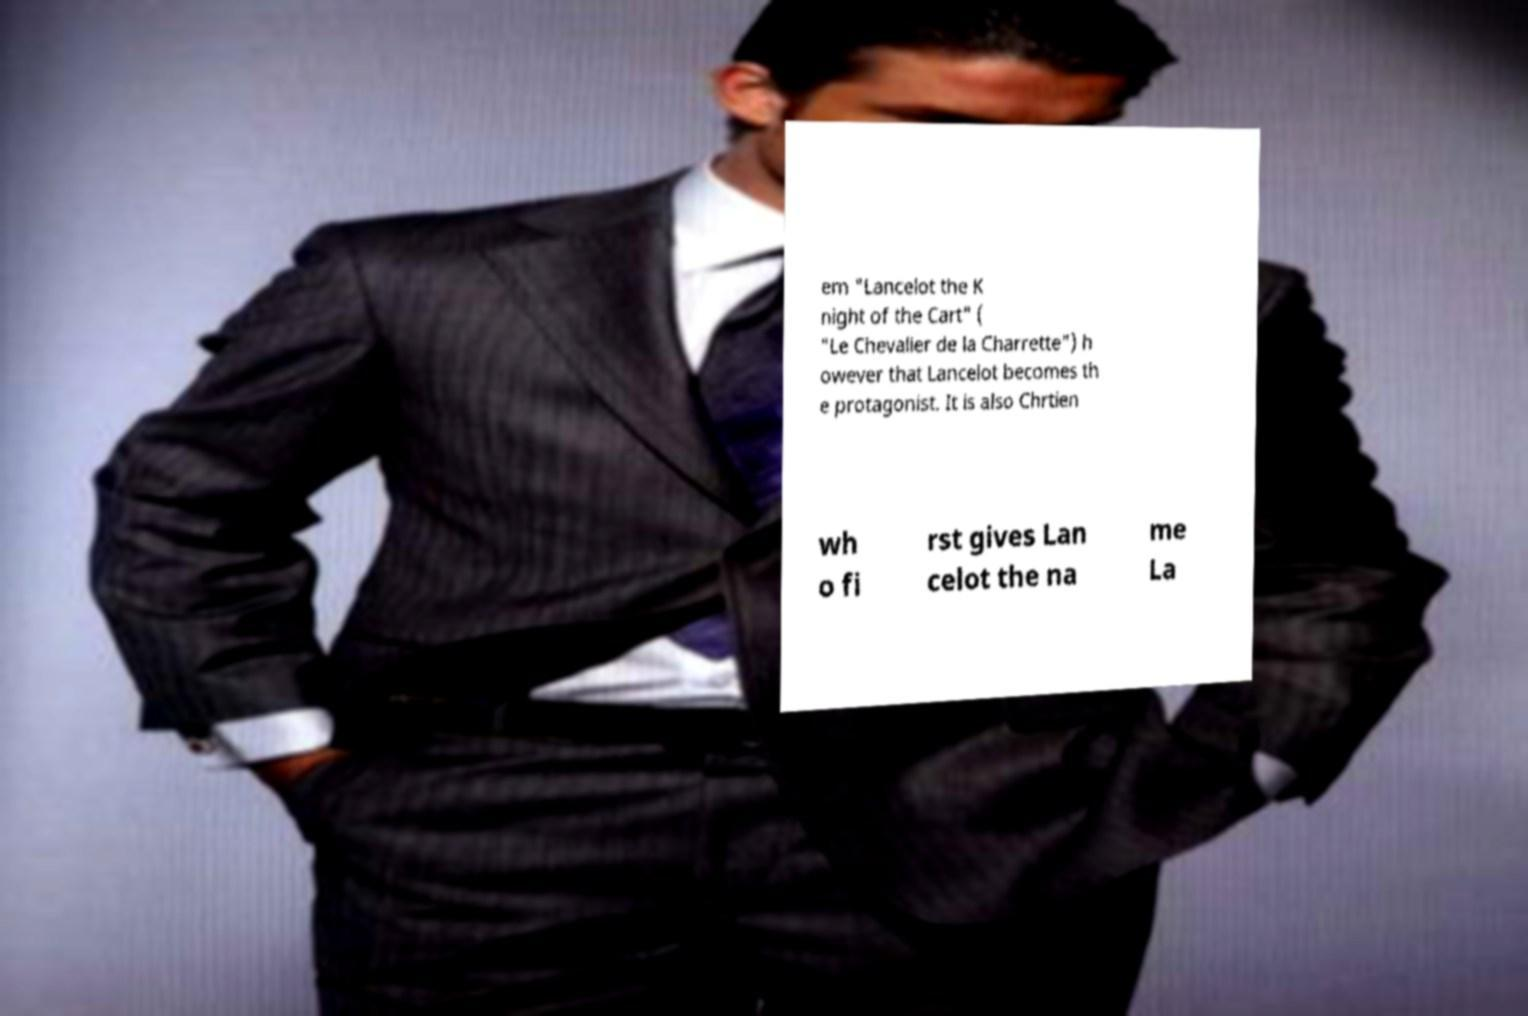There's text embedded in this image that I need extracted. Can you transcribe it verbatim? em "Lancelot the K night of the Cart" ( "Le Chevalier de la Charrette") h owever that Lancelot becomes th e protagonist. It is also Chrtien wh o fi rst gives Lan celot the na me La 